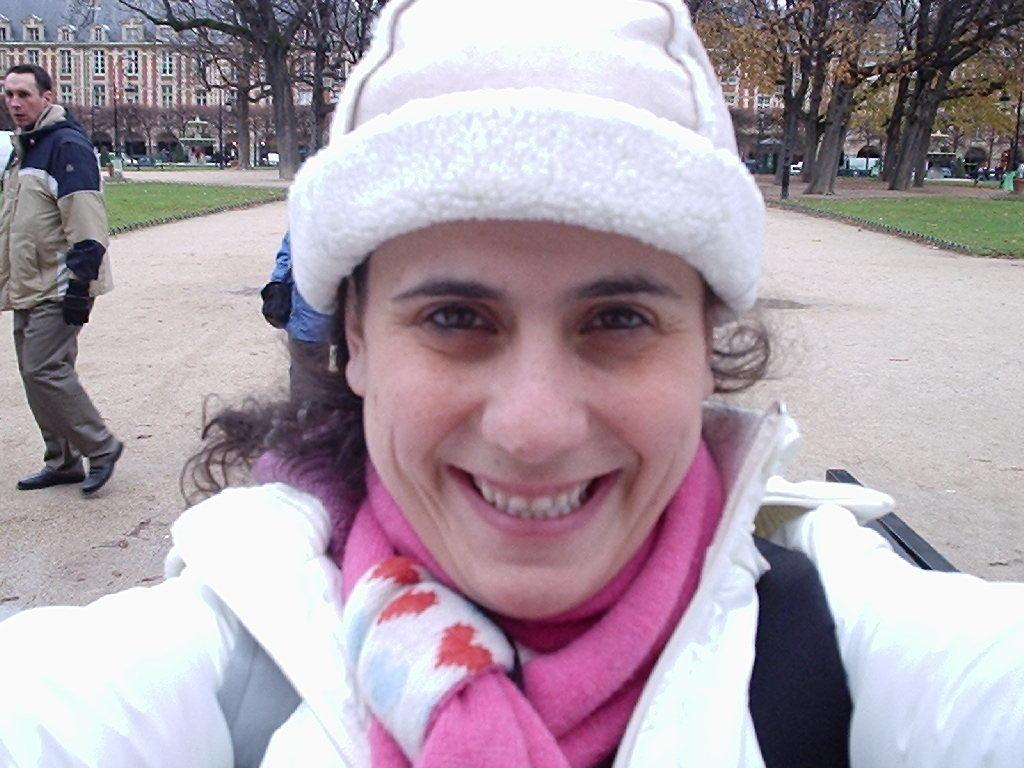What is the main subject of the image? There is a person in the image. What is the person wearing? The person is wearing a jacket and a hat. What can be seen in the background of the image? There are trees, plants, buildings, people, and vehicles in the background of the image. What is the texture of the lake in the image? There is no lake present in the image. What is the position of the person in relation to the vehicles in the background? The position of the person in relation to the vehicles cannot be determined from the image, as the person's exact location is not specified. 